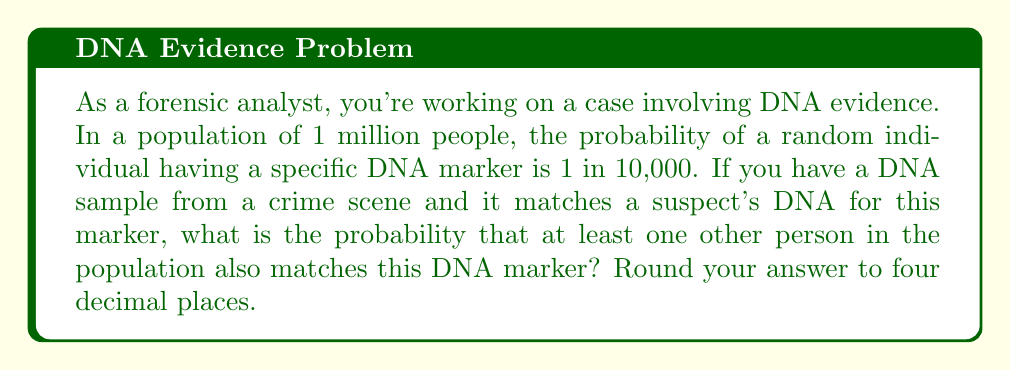Teach me how to tackle this problem. Let's approach this step-by-step:

1) First, we need to calculate the probability of a single person not matching the DNA marker:
   $P(\text{not matching}) = 1 - \frac{1}{10000} = 0.9999$

2) Now, we want to find the probability that all other people in the population (excluding the suspect) do not match. There are 999,999 other people in the population. The probability of this happening is:
   $P(\text{no one else matches}) = (0.9999)^{999999}$

3) Therefore, the probability that at least one other person matches is the complement of this:
   $P(\text{at least one other match}) = 1 - (0.9999)^{999999}$

4) Let's calculate this:
   $$\begin{align}
   P(\text{at least one other match}) &= 1 - (0.9999)^{999999} \\
   &= 1 - 0.9048 \\
   &= 0.0952
   \end{align}$$

5) Rounding to four decimal places, we get 0.0952.

This means there's about a 9.52% chance that at least one other person in the population matches the DNA marker.
Answer: 0.0952 